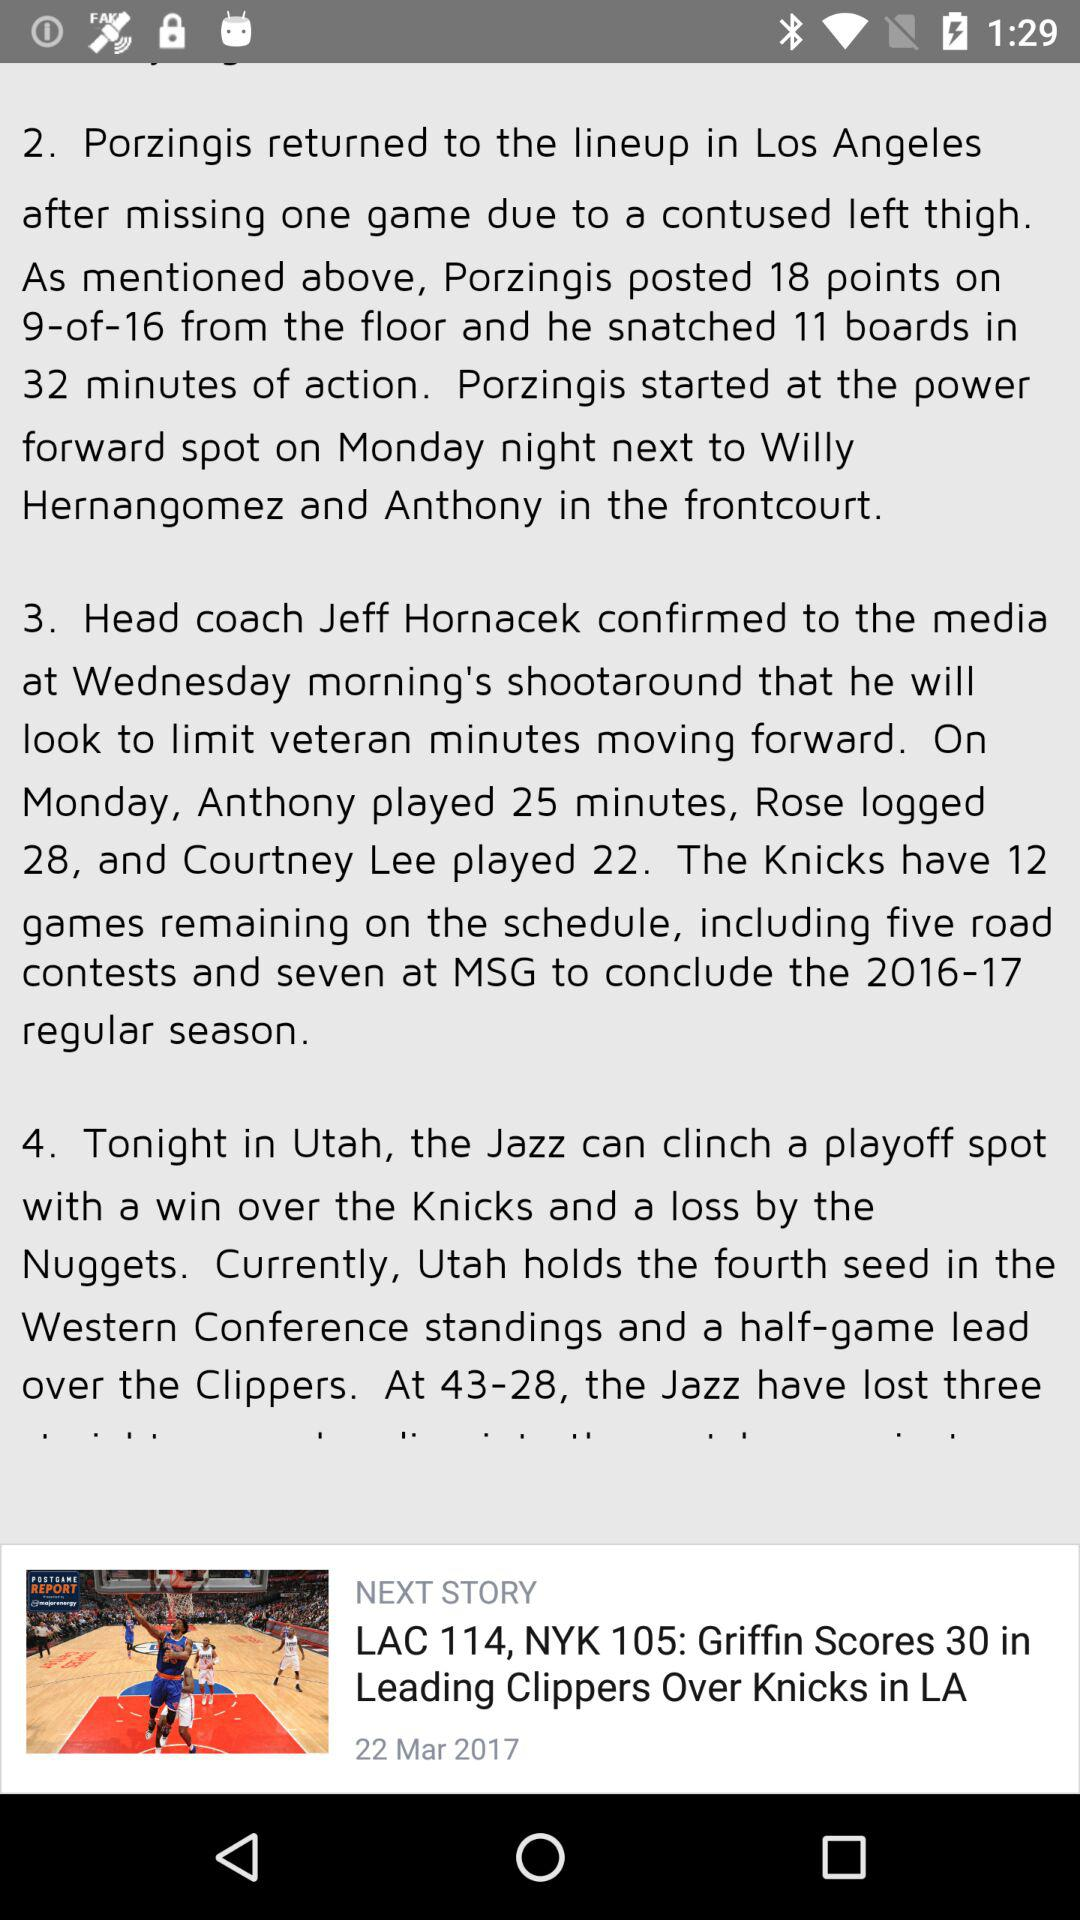How many more points did Griffin score than Porzingis?
Answer the question using a single word or phrase. 12 